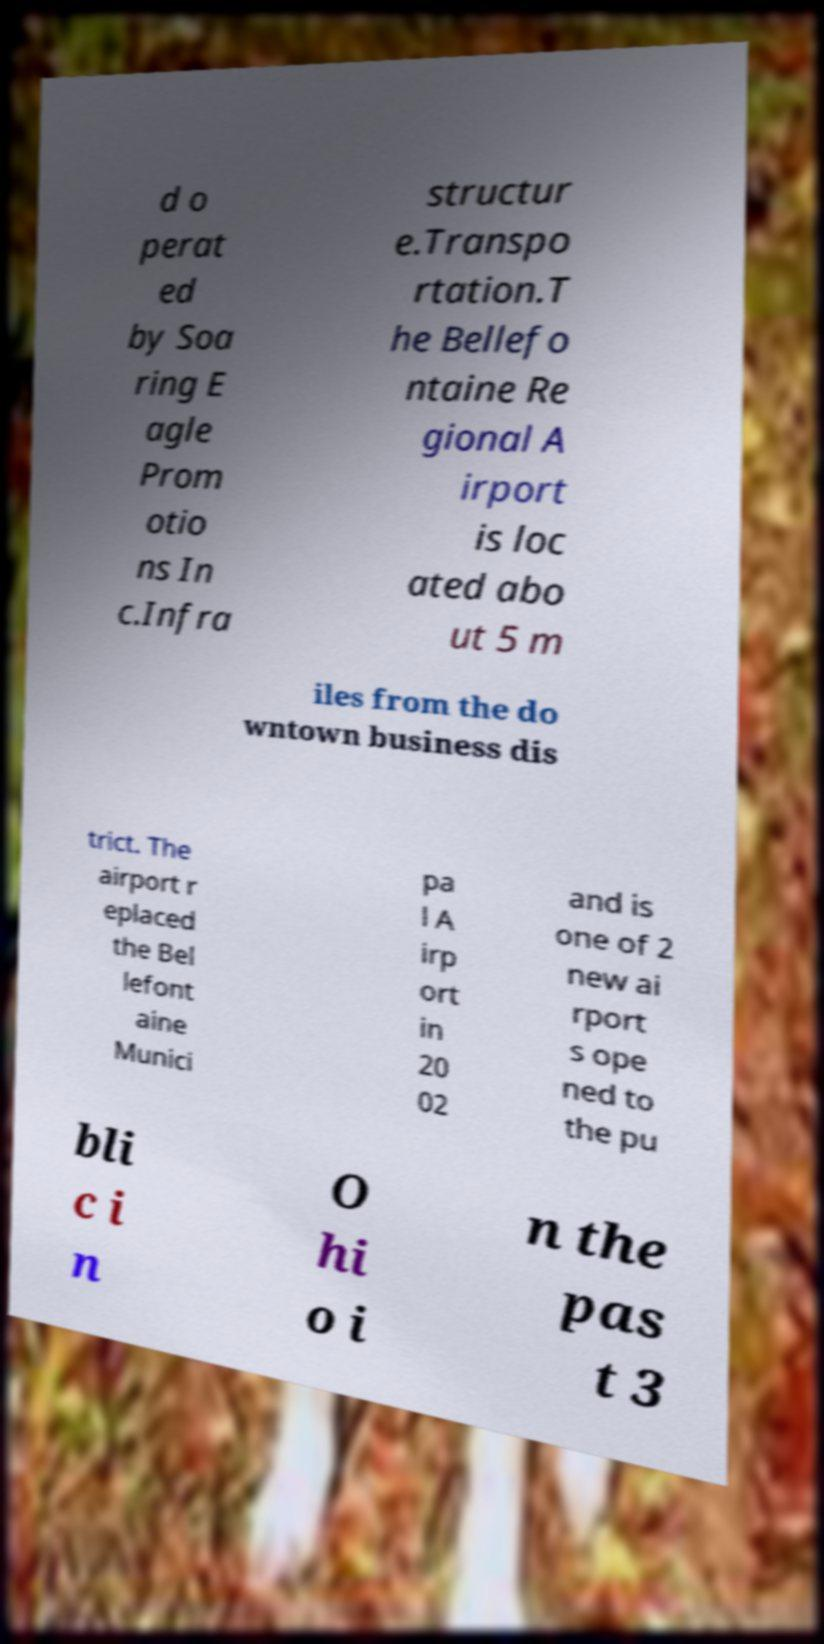Could you extract and type out the text from this image? d o perat ed by Soa ring E agle Prom otio ns In c.Infra structur e.Transpo rtation.T he Bellefo ntaine Re gional A irport is loc ated abo ut 5 m iles from the do wntown business dis trict. The airport r eplaced the Bel lefont aine Munici pa l A irp ort in 20 02 and is one of 2 new ai rport s ope ned to the pu bli c i n O hi o i n the pas t 3 